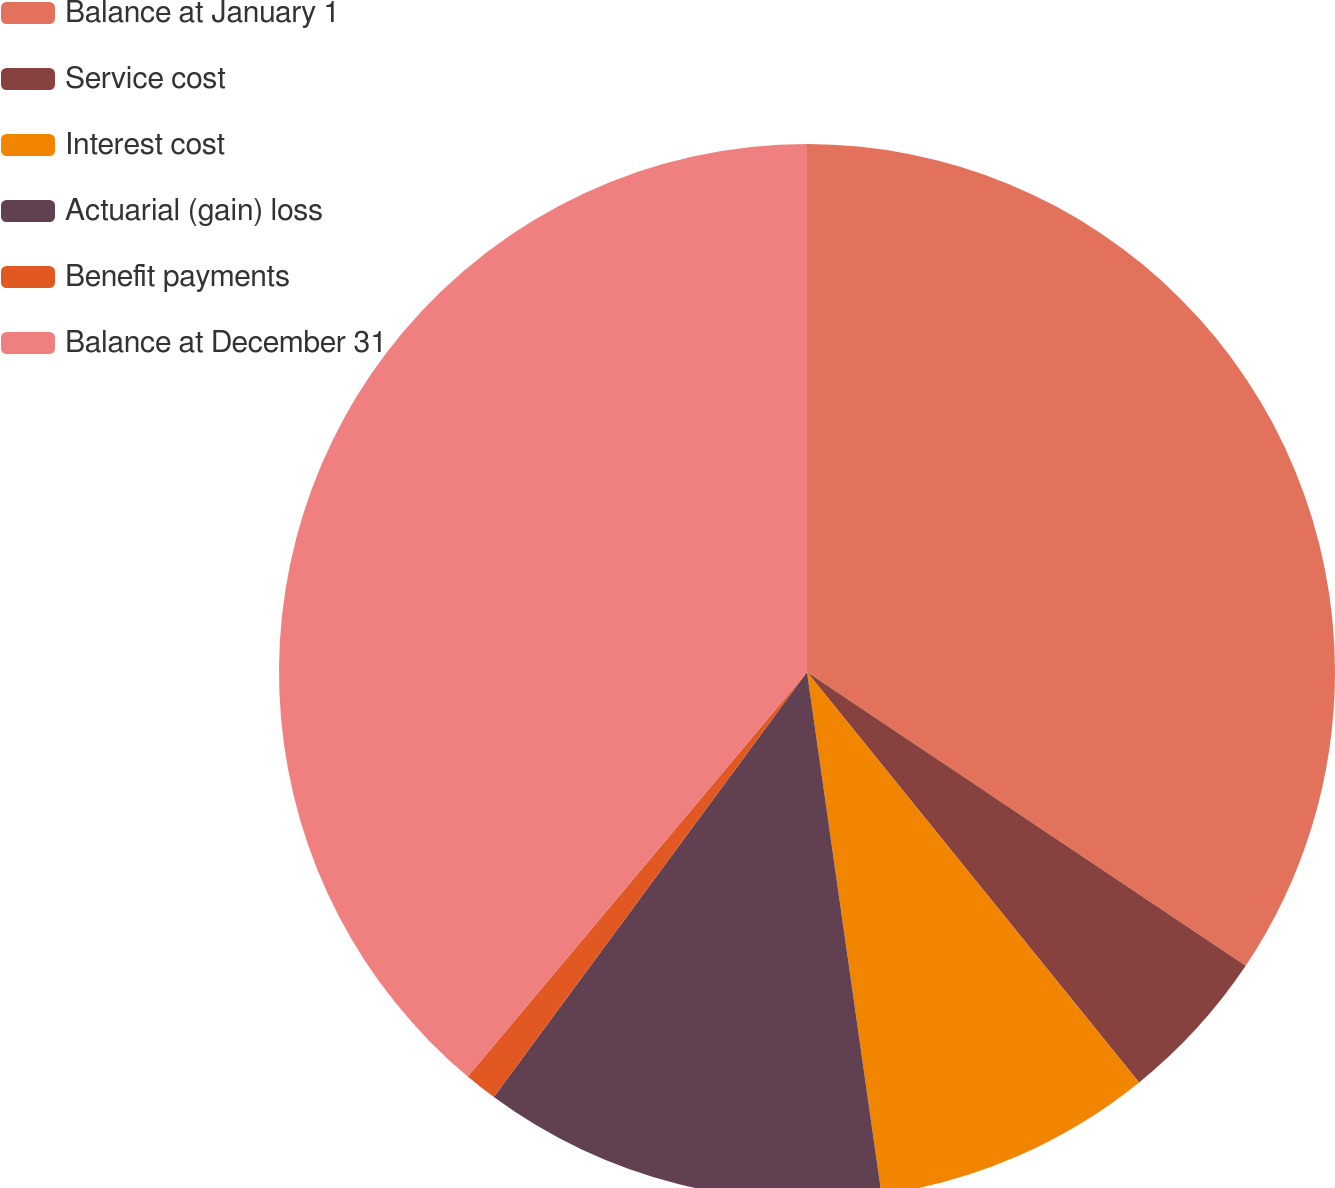Convert chart. <chart><loc_0><loc_0><loc_500><loc_500><pie_chart><fcel>Balance at January 1<fcel>Service cost<fcel>Interest cost<fcel>Actuarial (gain) loss<fcel>Benefit payments<fcel>Balance at December 31<nl><fcel>34.39%<fcel>4.78%<fcel>8.57%<fcel>12.36%<fcel>1.0%<fcel>38.89%<nl></chart> 